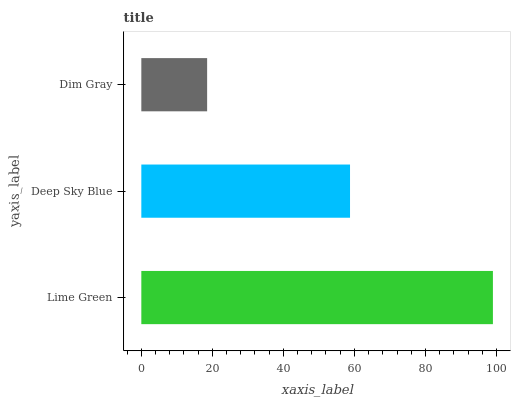Is Dim Gray the minimum?
Answer yes or no. Yes. Is Lime Green the maximum?
Answer yes or no. Yes. Is Deep Sky Blue the minimum?
Answer yes or no. No. Is Deep Sky Blue the maximum?
Answer yes or no. No. Is Lime Green greater than Deep Sky Blue?
Answer yes or no. Yes. Is Deep Sky Blue less than Lime Green?
Answer yes or no. Yes. Is Deep Sky Blue greater than Lime Green?
Answer yes or no. No. Is Lime Green less than Deep Sky Blue?
Answer yes or no. No. Is Deep Sky Blue the high median?
Answer yes or no. Yes. Is Deep Sky Blue the low median?
Answer yes or no. Yes. Is Lime Green the high median?
Answer yes or no. No. Is Lime Green the low median?
Answer yes or no. No. 